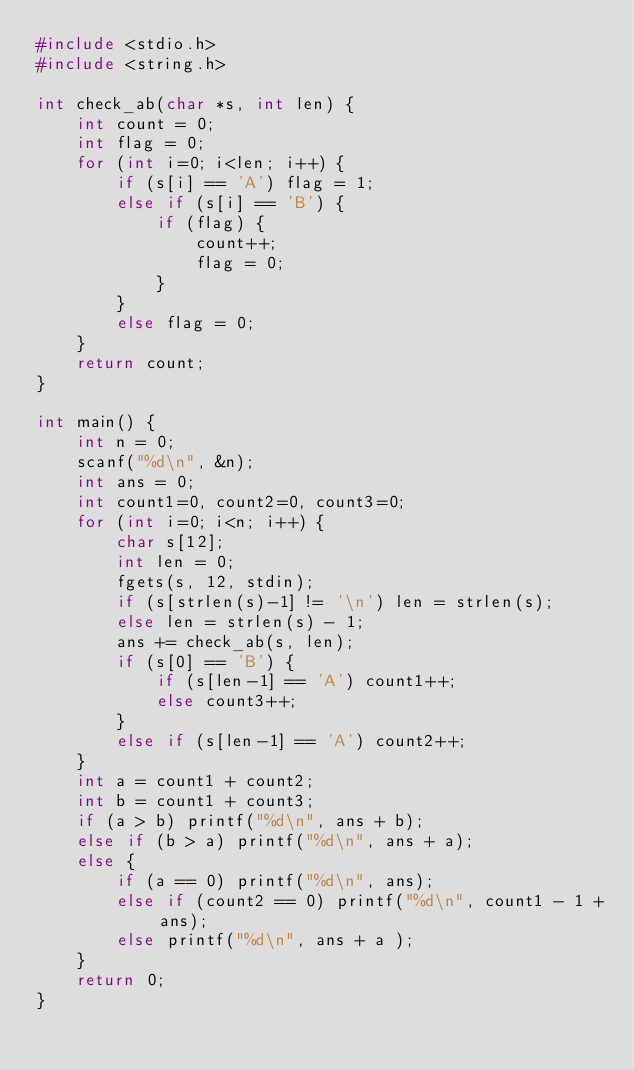<code> <loc_0><loc_0><loc_500><loc_500><_C_>#include <stdio.h>
#include <string.h>

int check_ab(char *s, int len) {
    int count = 0;
    int flag = 0;
    for (int i=0; i<len; i++) {
        if (s[i] == 'A') flag = 1;
        else if (s[i] == 'B') {
            if (flag) {
                count++;
                flag = 0;
            }
        }
        else flag = 0;
    }
    return count;
}

int main() {
    int n = 0;
    scanf("%d\n", &n);
    int ans = 0;
    int count1=0, count2=0, count3=0;
    for (int i=0; i<n; i++) {
        char s[12];
        int len = 0;
        fgets(s, 12, stdin);
        if (s[strlen(s)-1] != '\n') len = strlen(s);
        else len = strlen(s) - 1;
        ans += check_ab(s, len);
        if (s[0] == 'B') {
            if (s[len-1] == 'A') count1++;
            else count3++;
        }
        else if (s[len-1] == 'A') count2++;
    }
    int a = count1 + count2;
    int b = count1 + count3;
    if (a > b) printf("%d\n", ans + b);
    else if (b > a) printf("%d\n", ans + a);
    else {
        if (a == 0) printf("%d\n", ans);
        else if (count2 == 0) printf("%d\n", count1 - 1 + ans);
        else printf("%d\n", ans + a );
    }
    return 0;
}
</code> 